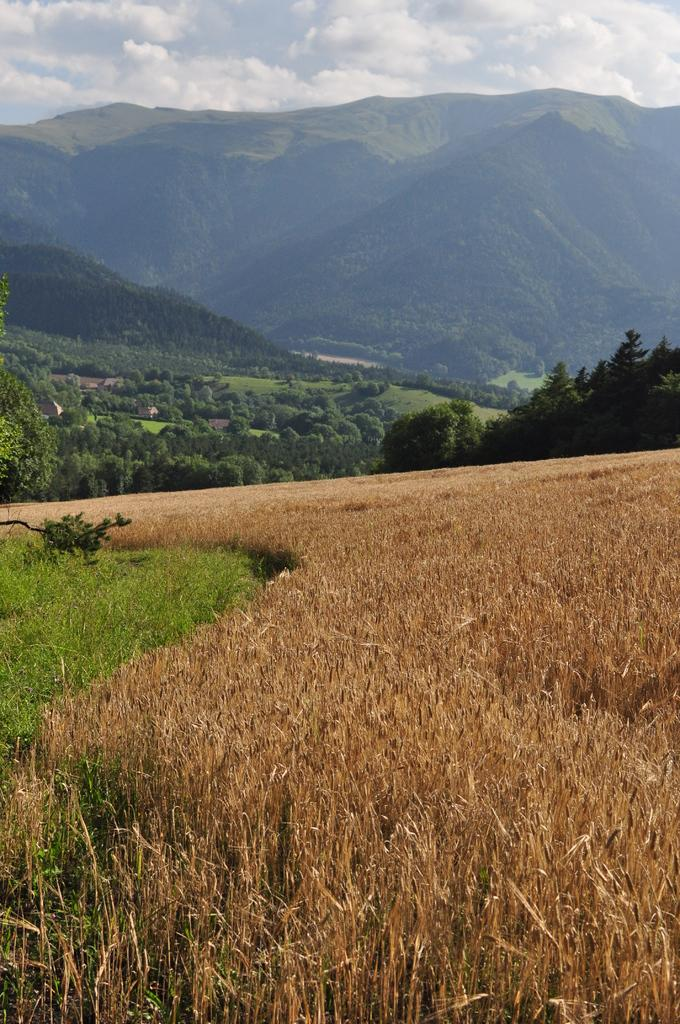What type of vegetation can be seen in the image? There is green and dry grass in the image. What other natural elements are present in the image? There are trees and hills visible in the image. What is visible in the background of the image? The sky is visible in the image. Can you tell me how many lawyers are sitting on the stove in the image? There are no lawyers or stoves present in the image. 